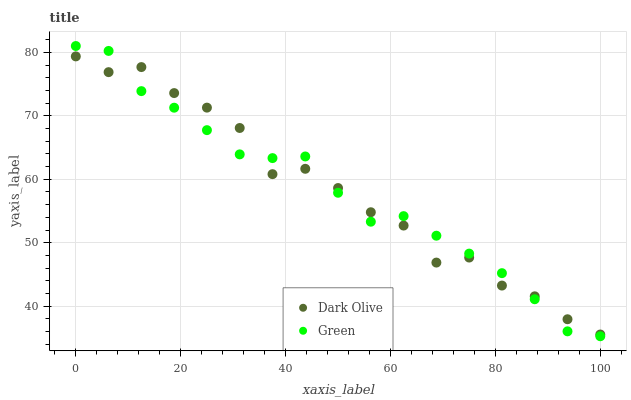Does Green have the minimum area under the curve?
Answer yes or no. Yes. Does Dark Olive have the maximum area under the curve?
Answer yes or no. Yes. Does Green have the maximum area under the curve?
Answer yes or no. No. Is Green the smoothest?
Answer yes or no. Yes. Is Dark Olive the roughest?
Answer yes or no. Yes. Is Green the roughest?
Answer yes or no. No. Does Green have the lowest value?
Answer yes or no. Yes. Does Green have the highest value?
Answer yes or no. Yes. Does Green intersect Dark Olive?
Answer yes or no. Yes. Is Green less than Dark Olive?
Answer yes or no. No. Is Green greater than Dark Olive?
Answer yes or no. No. 